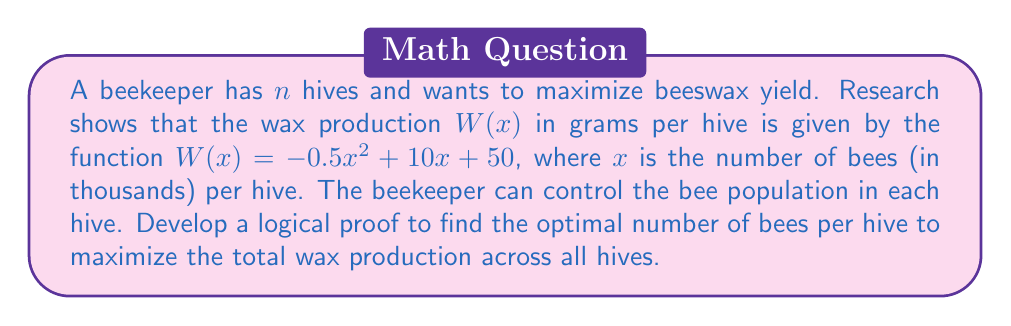Teach me how to tackle this problem. To develop a logical proof for maximizing beeswax yield, we'll follow these steps:

1) First, we need to find the function for total wax production across all hives:
   $$ T(x) = n \cdot W(x) = n(-0.5x^2 + 10x + 50) $$

2) To find the maximum of this function, we need to find where its derivative equals zero:
   $$ T'(x) = n(-x + 10) $$

3) Set this equal to zero and solve for x:
   $$ n(-x + 10) = 0 $$
   $$ -x + 10 = 0 $$
   $$ x = 10 $$

4) To confirm this is a maximum, we check the second derivative:
   $$ T''(x) = -n $$
   Since $n$ is positive (number of hives), $T''(x)$ is always negative, confirming a maximum.

5) Therefore, the optimal number of bees per hive is 10,000 (remember x was in thousands).

6) We can prove this is the global maximum using the following logic:
   - The function $W(x)$ is a quadratic function with a negative leading coefficient.
   - Such functions have a single global maximum.
   - We found the point where the derivative is zero, which must be this global maximum.
   - Multiplying $W(x)$ by a positive constant $n$ doesn't change the location of this maximum.

7) To calculate the maximum wax yield per hive:
   $$ W(10) = -0.5(10)^2 + 10(10) + 50 = -50 + 100 + 50 = 100 $$

8) Therefore, the maximum wax yield per hive is 100 grams.

9) The total maximum wax yield across all hives is:
   $$ T(10) = n \cdot W(10) = 100n $$
Answer: The optimal number of bees per hive to maximize wax production is 10,000. The maximum wax yield per hive is 100 grams, and the total maximum wax yield across all $n$ hives is $100n$ grams. 